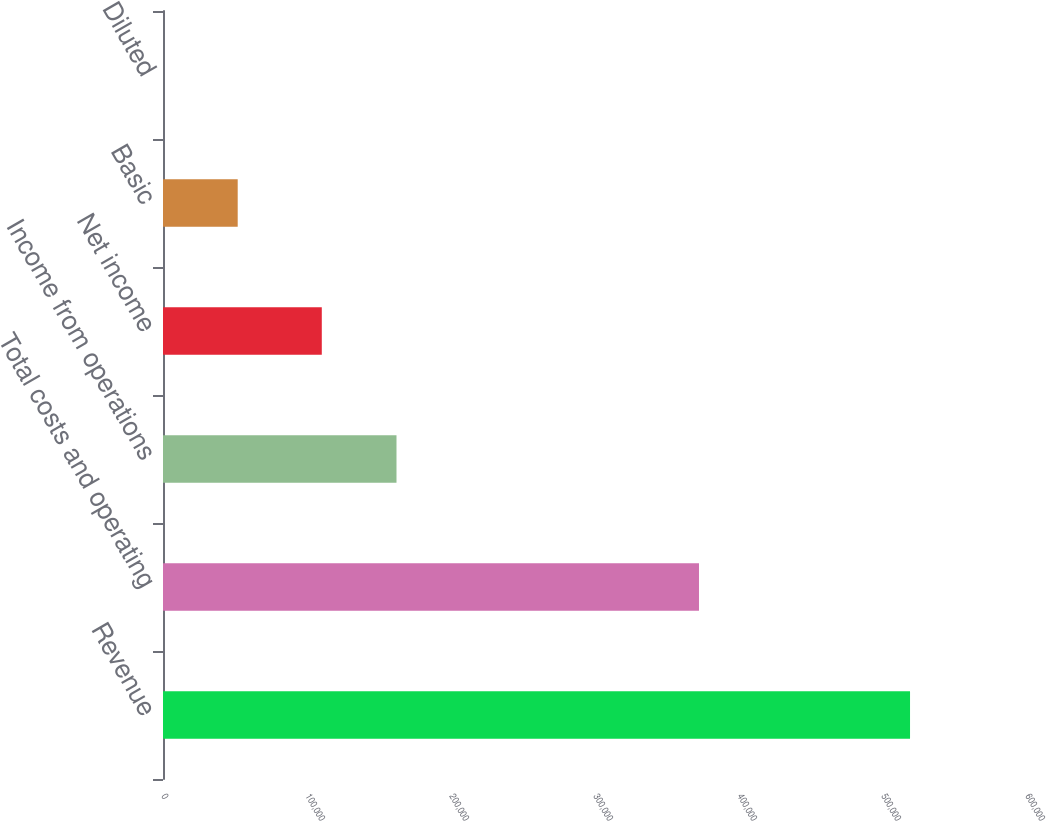Convert chart to OTSL. <chart><loc_0><loc_0><loc_500><loc_500><bar_chart><fcel>Revenue<fcel>Total costs and operating<fcel>Income from operations<fcel>Net income<fcel>Basic<fcel>Diluted<nl><fcel>518773<fcel>372213<fcel>162149<fcel>110272<fcel>51877.8<fcel>0.55<nl></chart> 